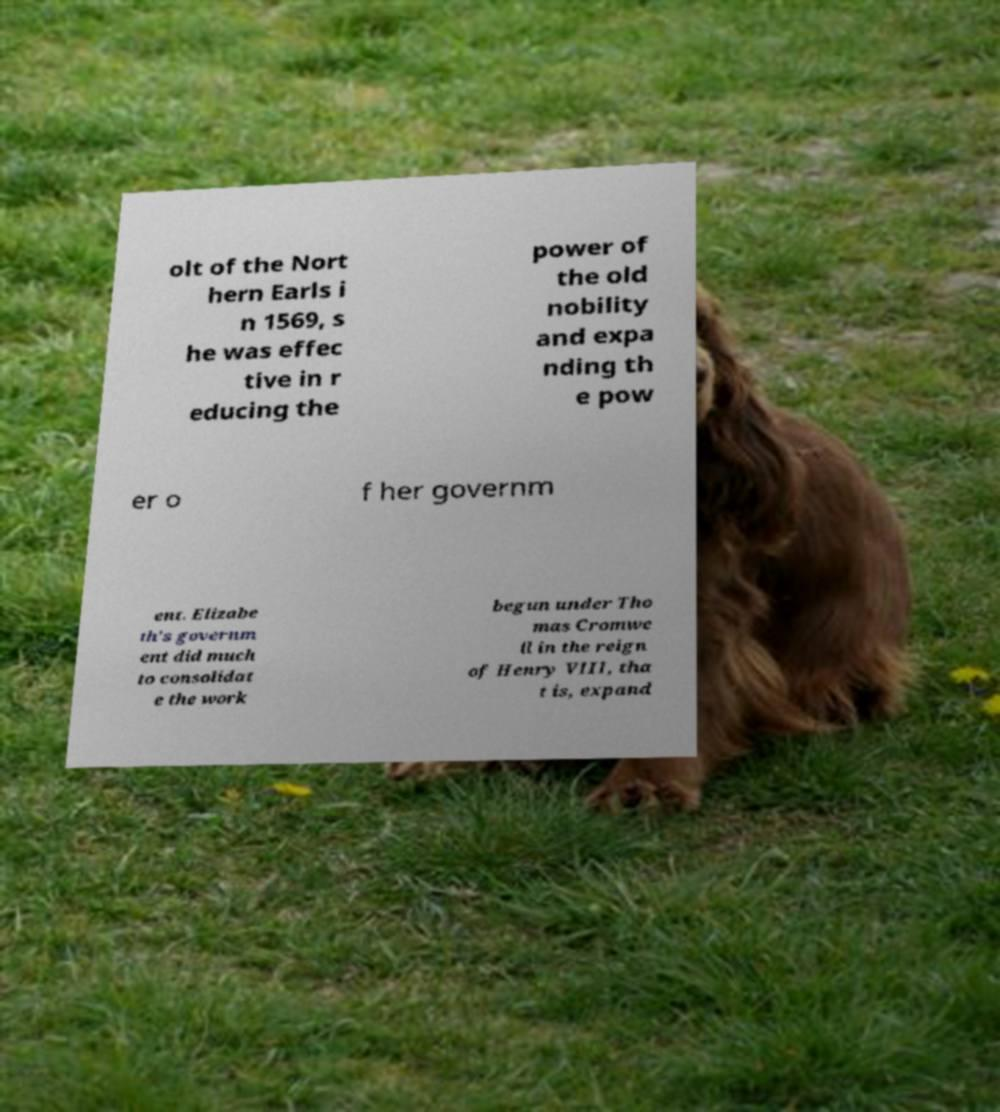For documentation purposes, I need the text within this image transcribed. Could you provide that? olt of the Nort hern Earls i n 1569, s he was effec tive in r educing the power of the old nobility and expa nding th e pow er o f her governm ent. Elizabe th's governm ent did much to consolidat e the work begun under Tho mas Cromwe ll in the reign of Henry VIII, tha t is, expand 